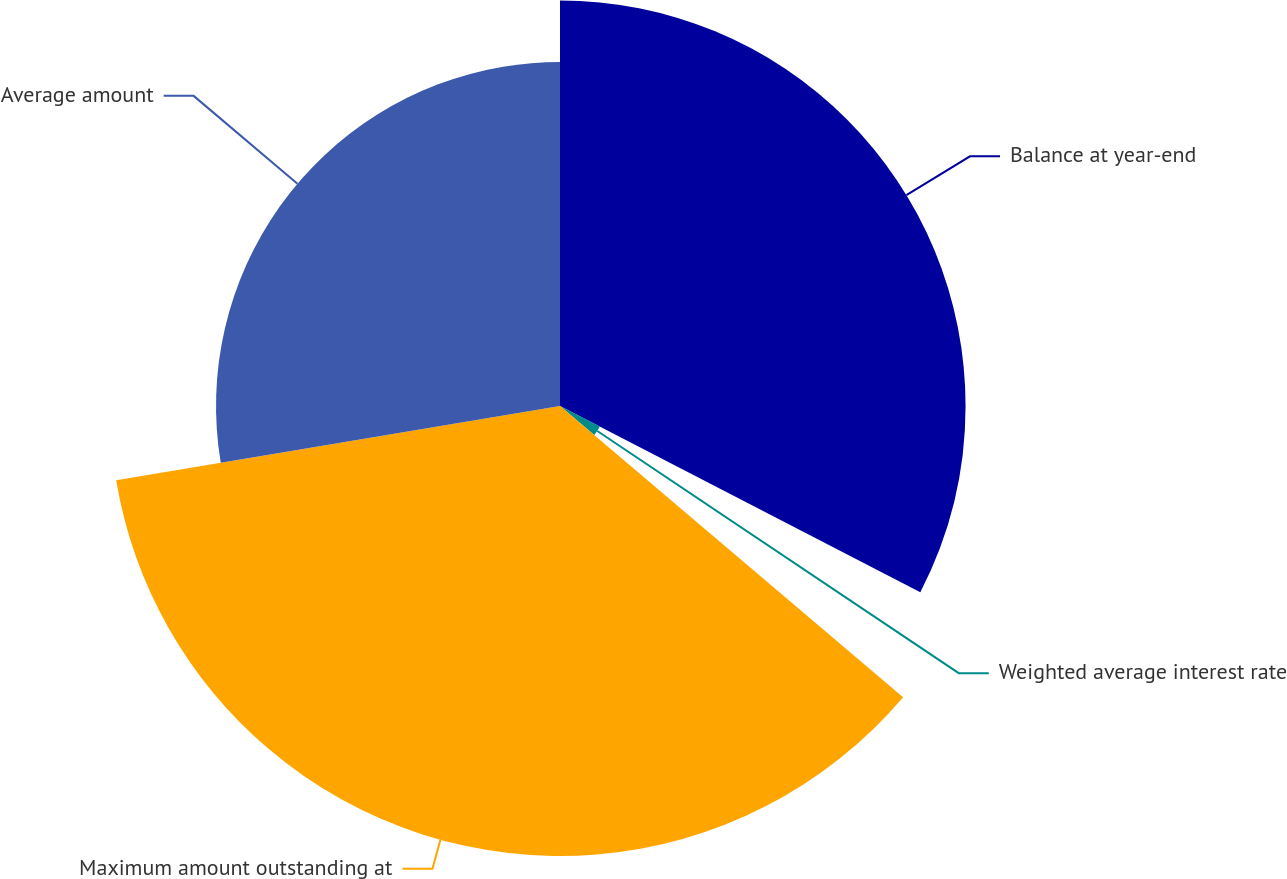<chart> <loc_0><loc_0><loc_500><loc_500><pie_chart><fcel>Balance at year-end<fcel>Weighted average interest rate<fcel>Maximum amount outstanding at<fcel>Average amount<nl><fcel>32.59%<fcel>3.61%<fcel>36.16%<fcel>27.64%<nl></chart> 